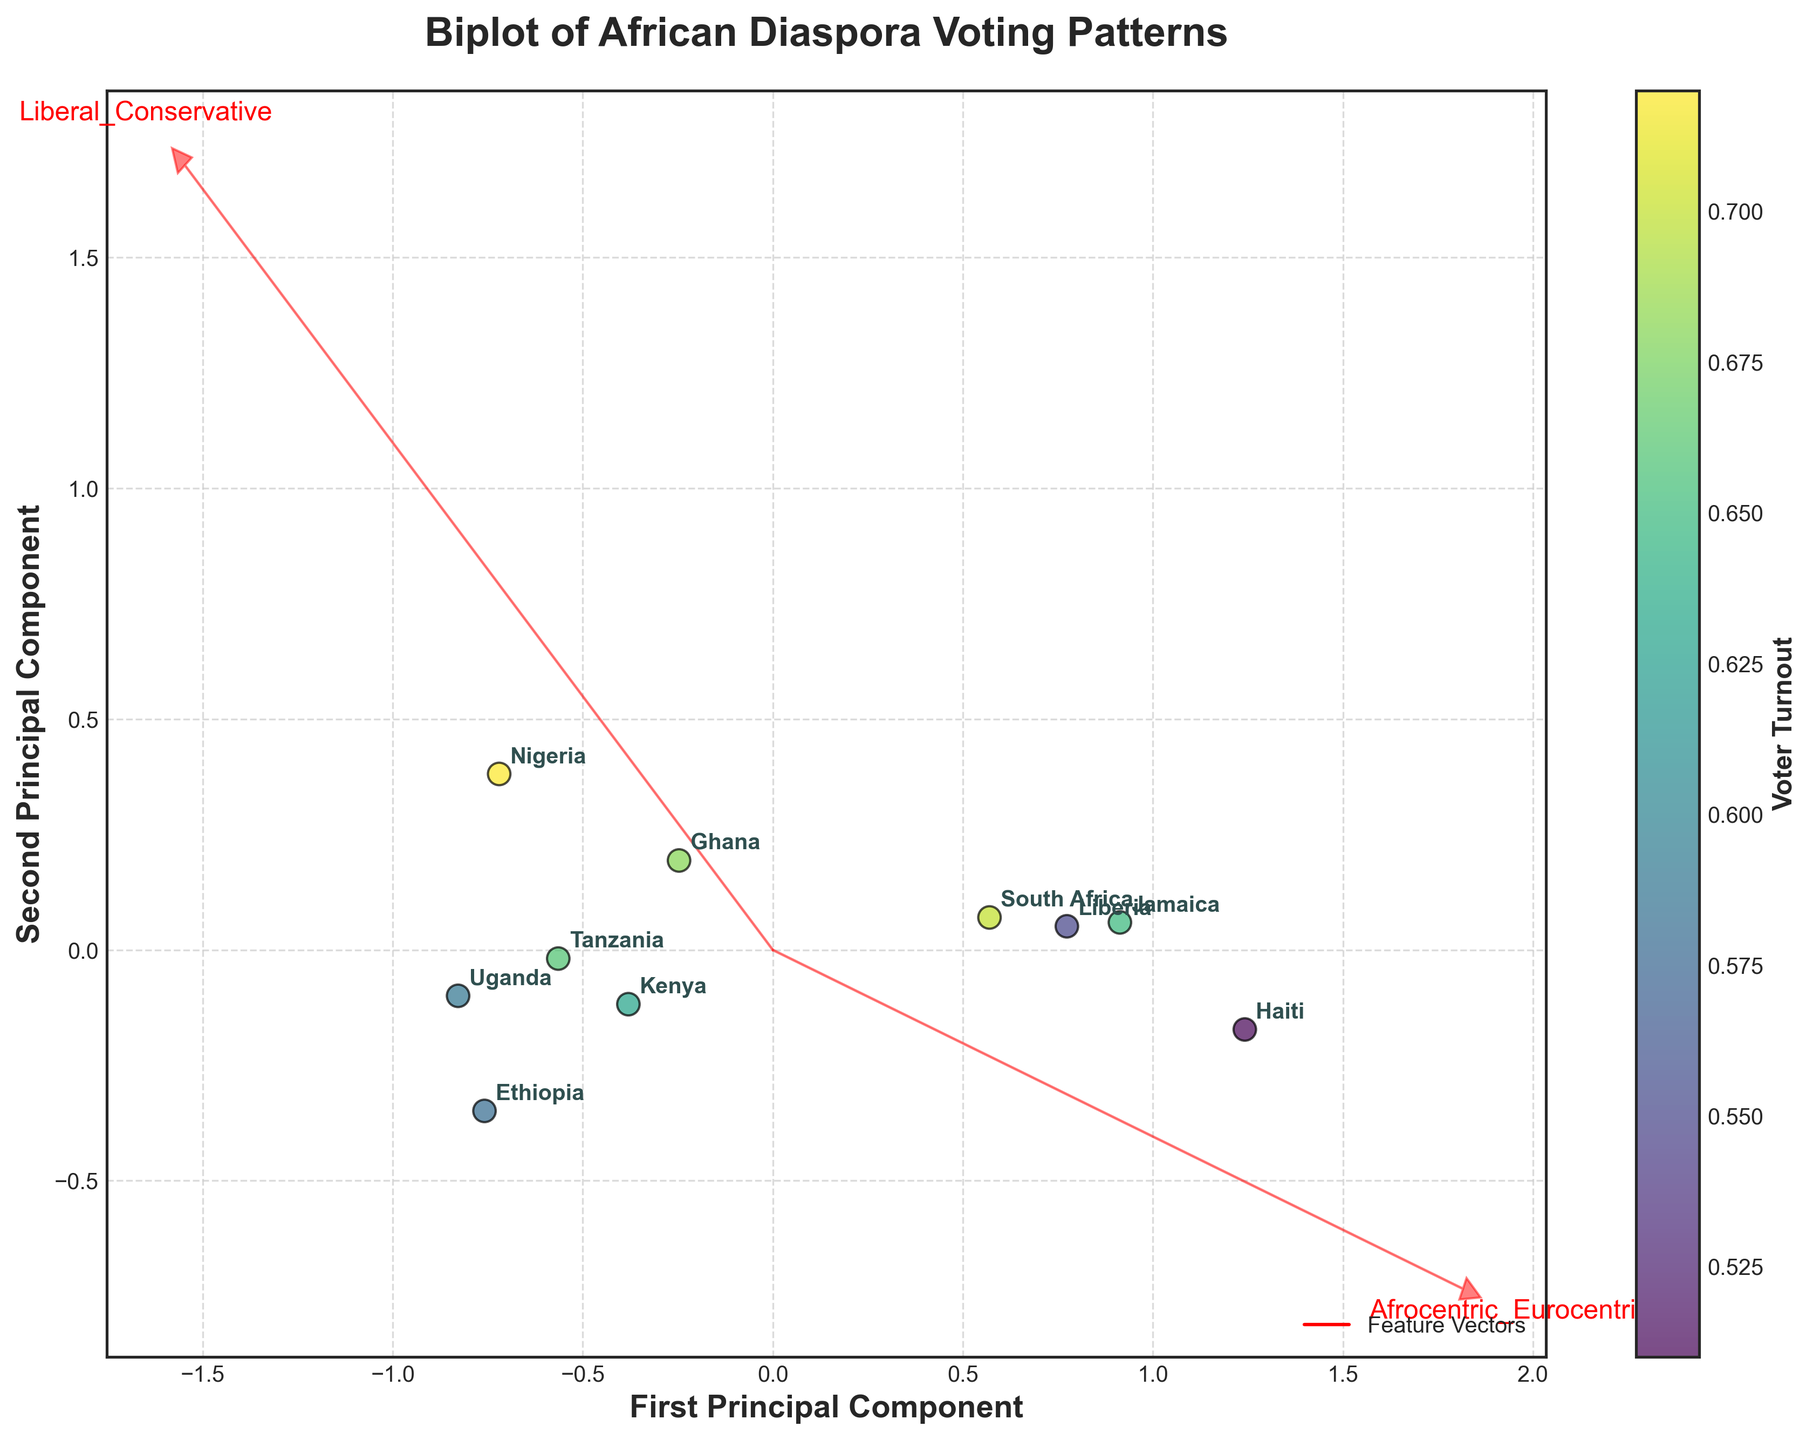How many countries are represented in the biplot? Count the number of labeled points on the plot; these correspond to the countries listed in the dataset. Each unique label on the plot represents a country.
Answer: 10 What does the color of the data points represent? The color gradient of the data points is indicated by the color bar next to the plot, labeled 'Voter Turnout'. This means the colors correlate with voter turnout rates.
Answer: Voter Turnout Which two countries are closest to each other in the biplot? Observe the positions of labeled data points. The two points that are nearest each other in the PCA plot are Tanzania and Ghana.
Answer: Tanzania and Ghana Are the features 'Liberal_Conservative' and 'Social_Progressive_Traditional' positively or negatively correlated? Check the direction and length of the feature vectors in the biplot. If the vectors for 'Liberal_Conservative' and 'Social_Progressive_Traditional' point roughly in the same direction, they are positively correlated, otherwise negatively. In this case, they point in slightly similar directions.
Answer: Positively correlated Which feature has the longest vector, indicating higher importance in the first principal component? Compare the length of the feature vectors from the origin. The feature with the longest arrow is most influential in distinguishing the data points along the first PCA component. 'Afrocentric_Eurocentric' has the longest vector.
Answer: Afrocentric_Eurocentric Which country has the highest voter turnout? Refer to the color gradient of the data points and the 'Voter Turnout' variable. The point with the color closest to the upper end of the color bar represents the highest voter turnout. Nigeria has the highest voter turnout.
Answer: Nigeria Are the first and second principal components equally important in explaining the variance in the data? Examine the labels on the axes and consider how the components separate the data points. The specific amounts of variance explained are not shown in the plot, but typically in PCA plots, the axis labels might provide this information if available. However, based on visual spread and annotation, this cannot be accurately determined.
Answer: Not explicitly stated How do Kenya and Uganda compare in terms of the feature represented by the x-axis? Observe the position of Kenya and Uganda along the first principal component (x-axis). Kenya is to the left and Uganda to the right, indicating that Kenya has a lower score and Uganda a higher score in the first principal component.
Answer: Uganda higher, Kenya lower Which country is the most Afrocentric and least conservative according to the biplot? Look for the position along the 'Afrocentric_Eurocentric' (feature vector direction) and 'Liberal_Conservative' vectors. Uganda is the most Afrocentric (high Afrocentric value, towards 'Afrocentric' direction) and not highly conservative.
Answer: Uganda 